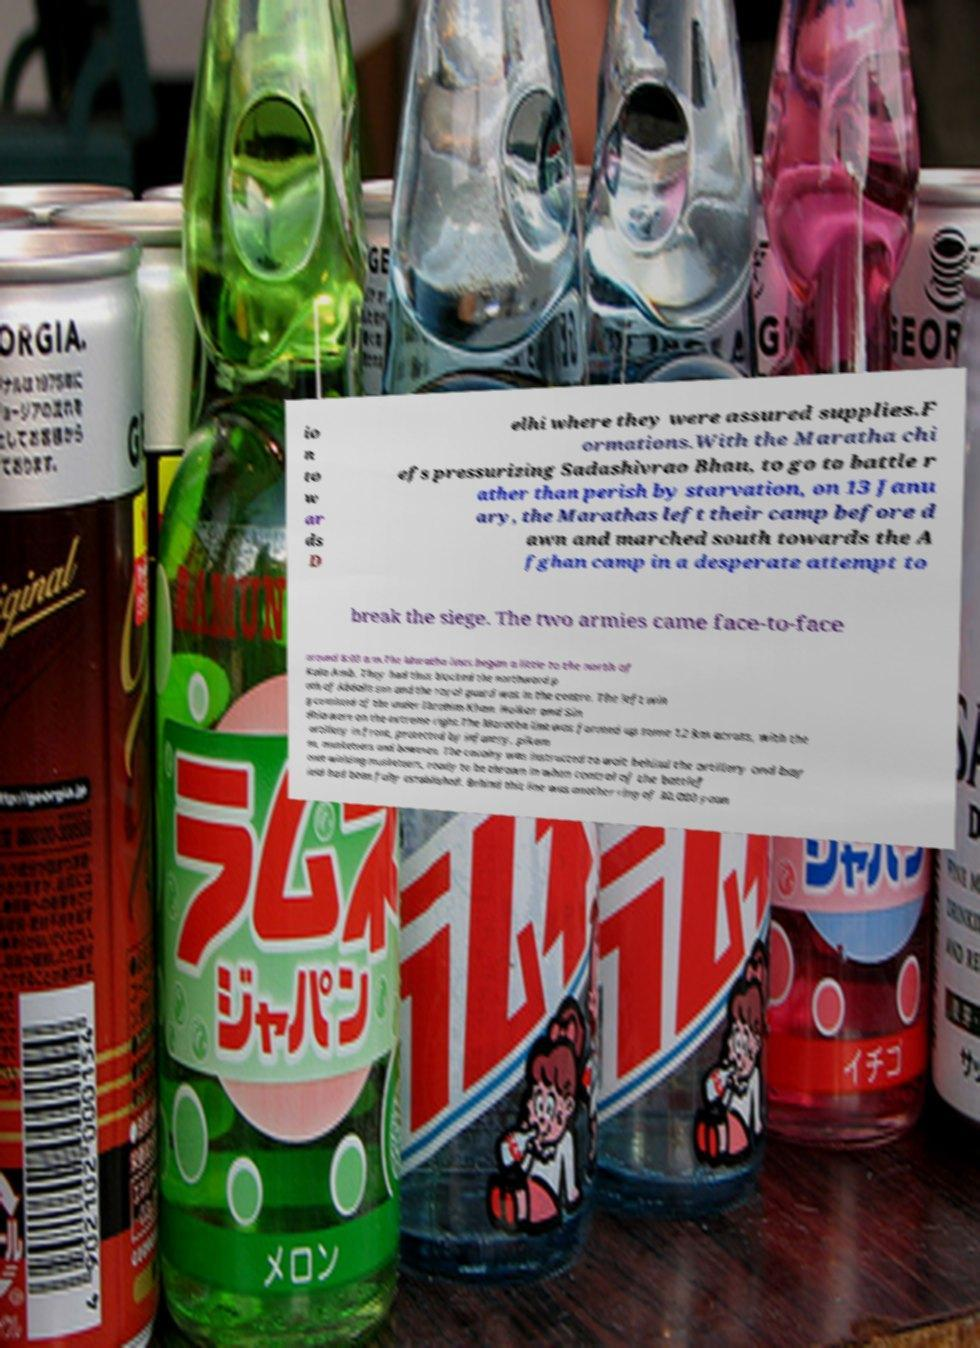Please identify and transcribe the text found in this image. io n to w ar ds D elhi where they were assured supplies.F ormations.With the Maratha chi efs pressurizing Sadashivrao Bhau, to go to battle r ather than perish by starvation, on 13 Janu ary, the Marathas left their camp before d awn and marched south towards the A fghan camp in a desperate attempt to break the siege. The two armies came face-to-face around 8:00 a.m.The Maratha lines began a little to the north of Kala Amb. They had thus blocked the northward p ath of Abdalis son and the royal guard was in the centre. The left win g consisted of the under Ibrahim Khan. Holkar and Sin dhia were on the extreme right.The Maratha line was formed up some 12 km across, with the artillery in front, protected by infantry, pikem en, musketeers and bowmen. The cavalry was instructed to wait behind the artillery and bay onet-wielding musketeers, ready to be thrown in when control of the battlef ield had been fully established. Behind this line was another ring of 30,000 youn 